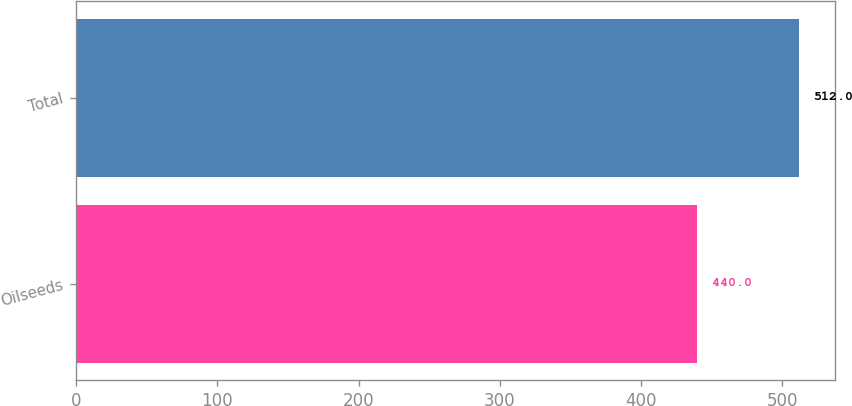Convert chart. <chart><loc_0><loc_0><loc_500><loc_500><bar_chart><fcel>Oilseeds<fcel>Total<nl><fcel>440<fcel>512<nl></chart> 